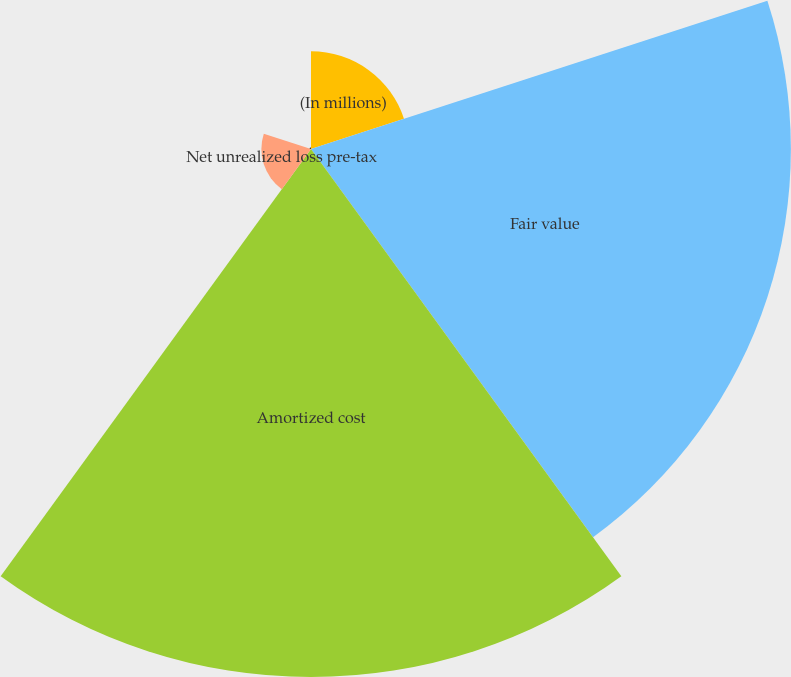<chart> <loc_0><loc_0><loc_500><loc_500><pie_chart><fcel>(In millions)<fcel>Fair value<fcel>Amortized cost<fcel>Net unrealized loss pre-tax<fcel>Net unrealized loss after-tax<nl><fcel>8.45%<fcel>41.48%<fcel>45.64%<fcel>4.29%<fcel>0.14%<nl></chart> 